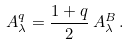<formula> <loc_0><loc_0><loc_500><loc_500>A _ { \lambda } ^ { q } = \frac { 1 + q } { 2 } \, A _ { \lambda } ^ { B } \, .</formula> 